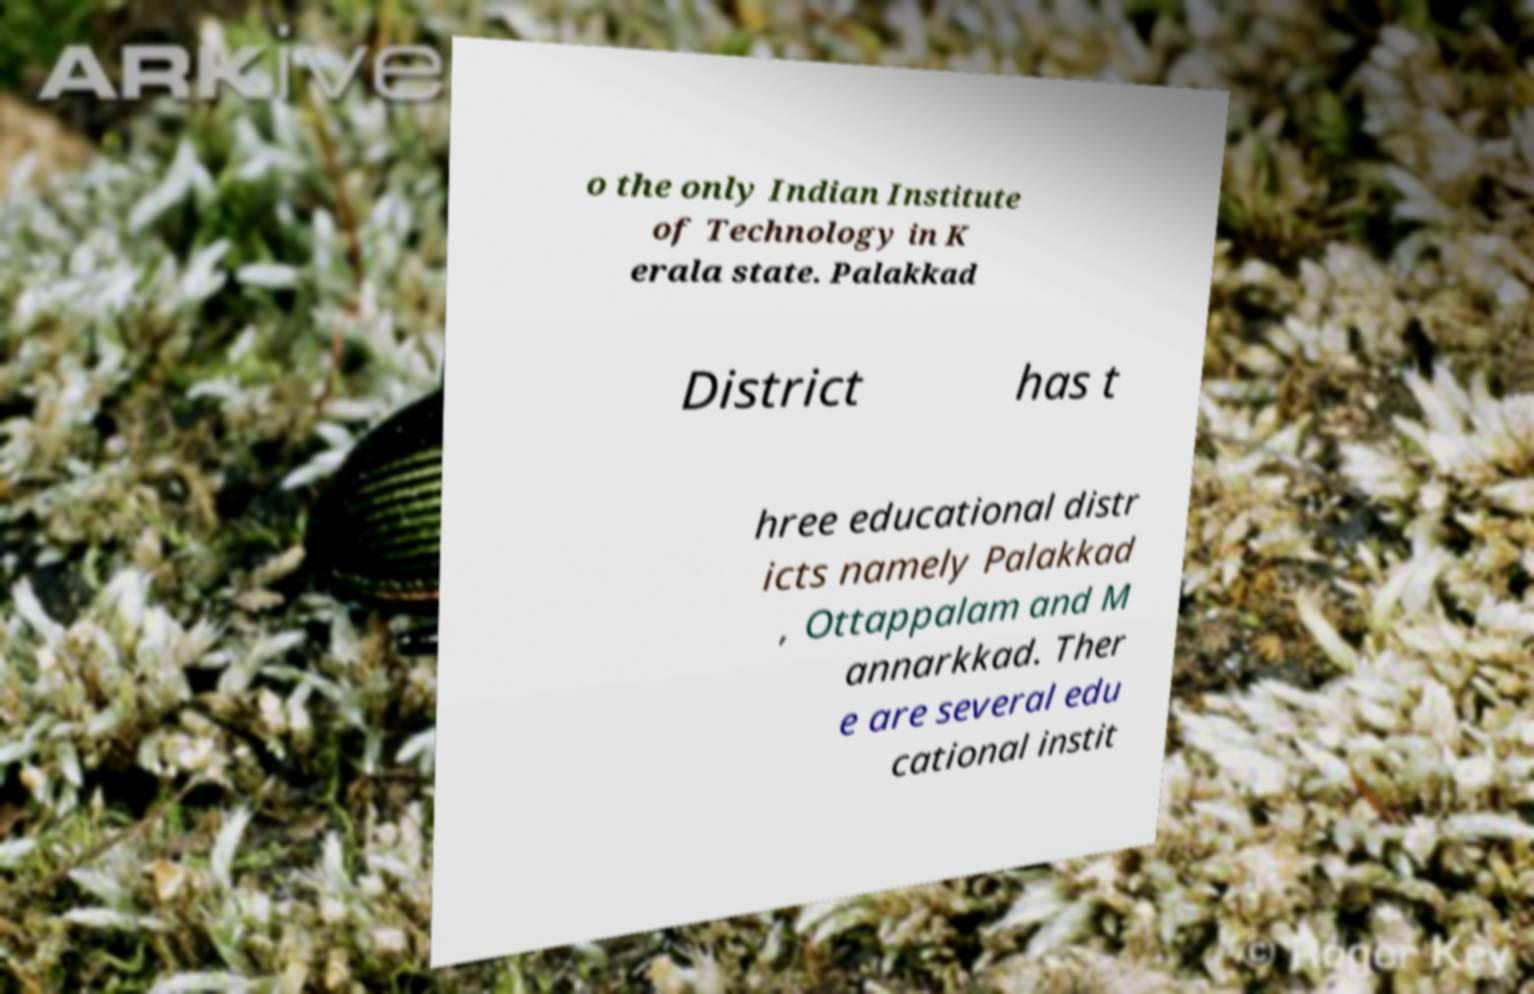Please read and relay the text visible in this image. What does it say? o the only Indian Institute of Technology in K erala state. Palakkad District has t hree educational distr icts namely Palakkad , Ottappalam and M annarkkad. Ther e are several edu cational instit 